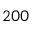Convert formula to latex. <formula><loc_0><loc_0><loc_500><loc_500>2 0 0</formula> 